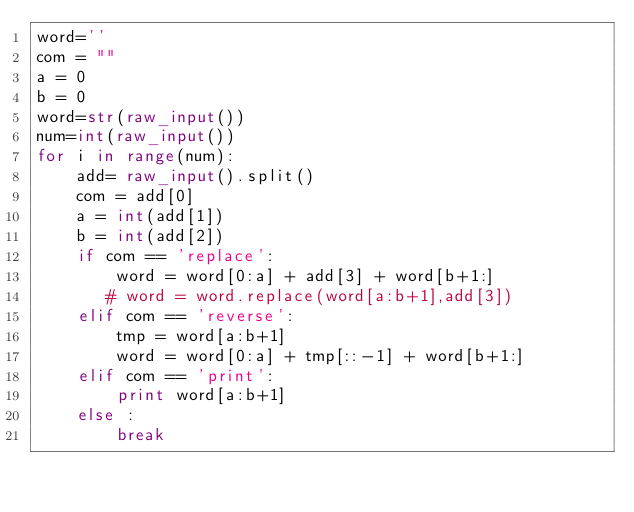<code> <loc_0><loc_0><loc_500><loc_500><_Python_>word=''
com = ""
a = 0
b = 0
word=str(raw_input())
num=int(raw_input())
for i in range(num):
    add= raw_input().split()
    com = add[0]
    a = int(add[1])
    b = int(add[2])
    if com == 'replace':
        word = word[0:a] + add[3] + word[b+1:]
       # word = word.replace(word[a:b+1],add[3])
    elif com == 'reverse':
        tmp = word[a:b+1]
        word = word[0:a] + tmp[::-1] + word[b+1:]
    elif com == 'print':
        print word[a:b+1]
    else :
        break</code> 